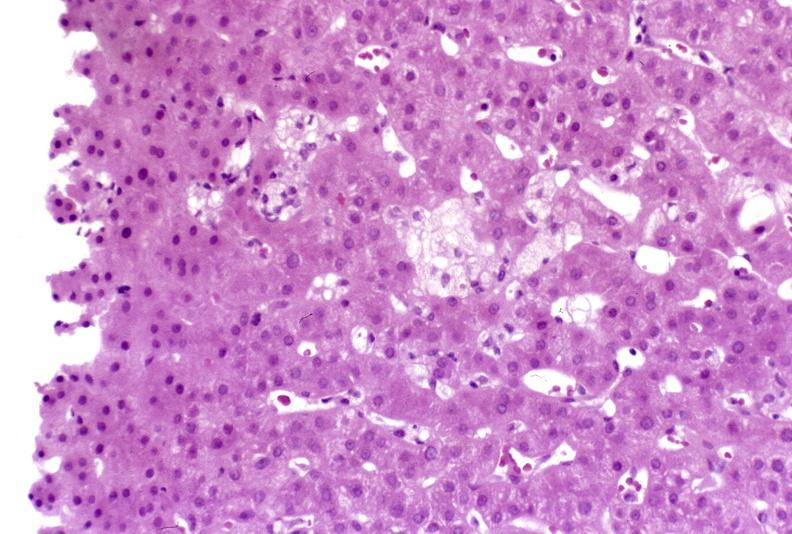does endometritis postpartum show recovery of ducts?
Answer the question using a single word or phrase. No 